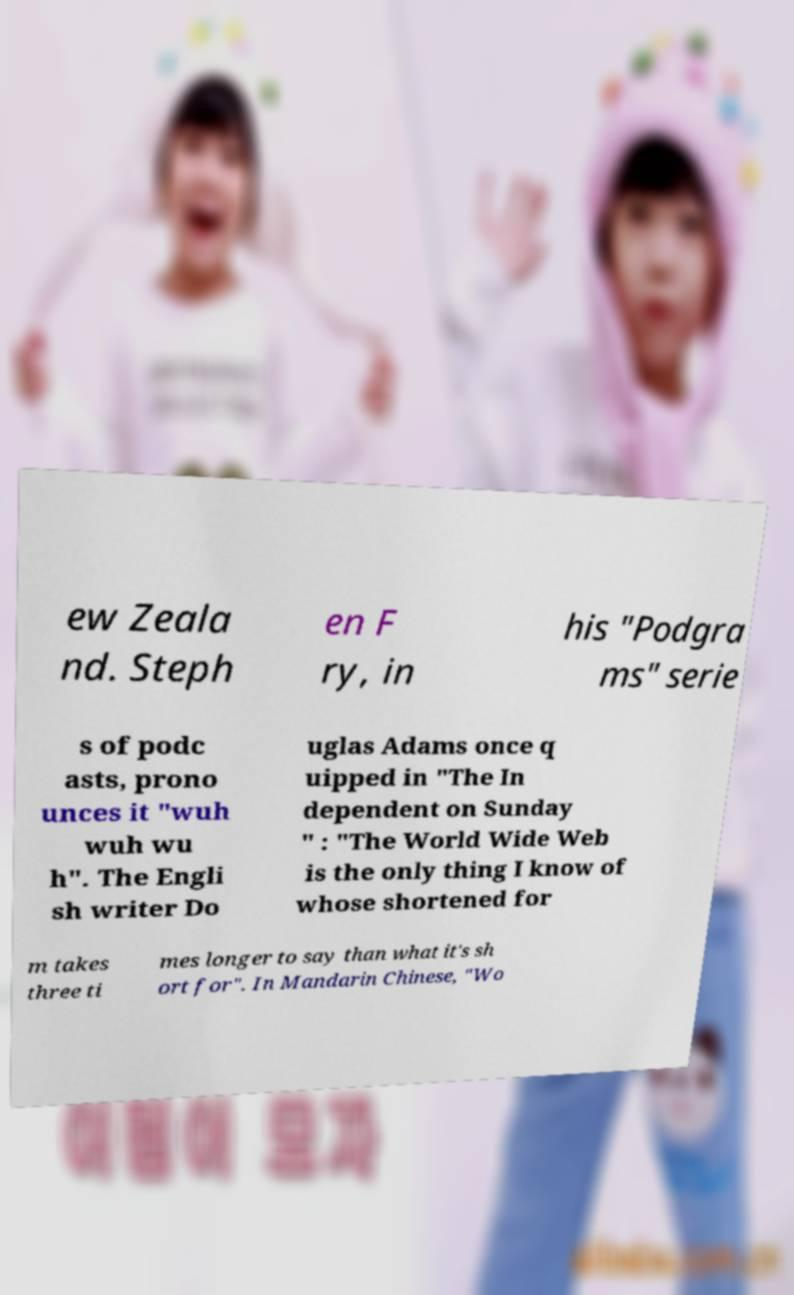For documentation purposes, I need the text within this image transcribed. Could you provide that? ew Zeala nd. Steph en F ry, in his "Podgra ms" serie s of podc asts, prono unces it "wuh wuh wu h". The Engli sh writer Do uglas Adams once q uipped in "The In dependent on Sunday " : "The World Wide Web is the only thing I know of whose shortened for m takes three ti mes longer to say than what it's sh ort for". In Mandarin Chinese, "Wo 